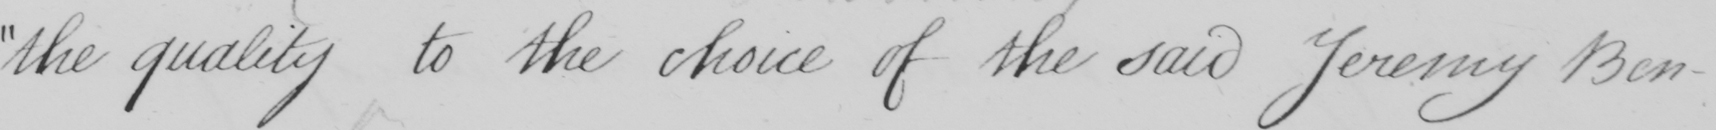Please transcribe the handwritten text in this image. the quality to the choice of the said Jeremy Ben- 